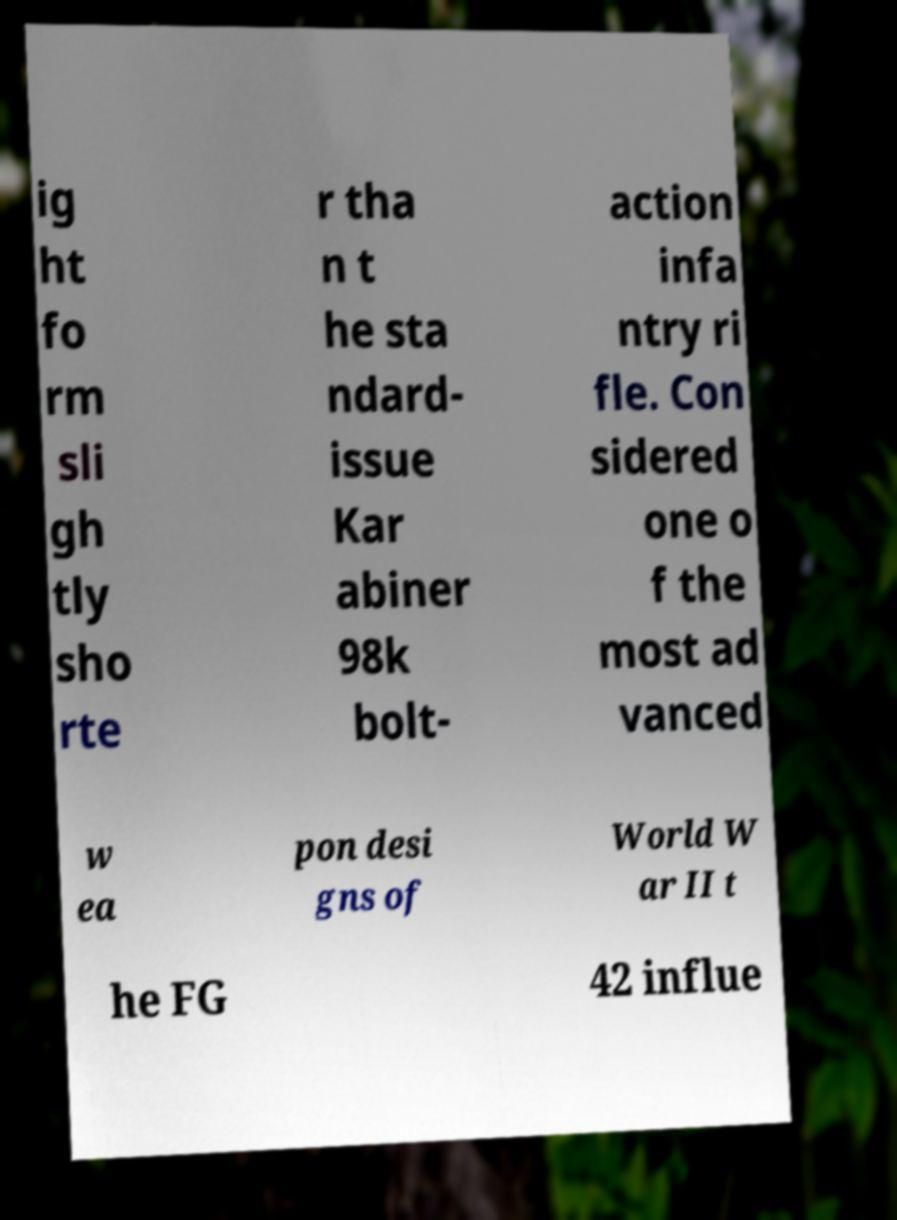Could you extract and type out the text from this image? ig ht fo rm sli gh tly sho rte r tha n t he sta ndard- issue Kar abiner 98k bolt- action infa ntry ri fle. Con sidered one o f the most ad vanced w ea pon desi gns of World W ar II t he FG 42 influe 